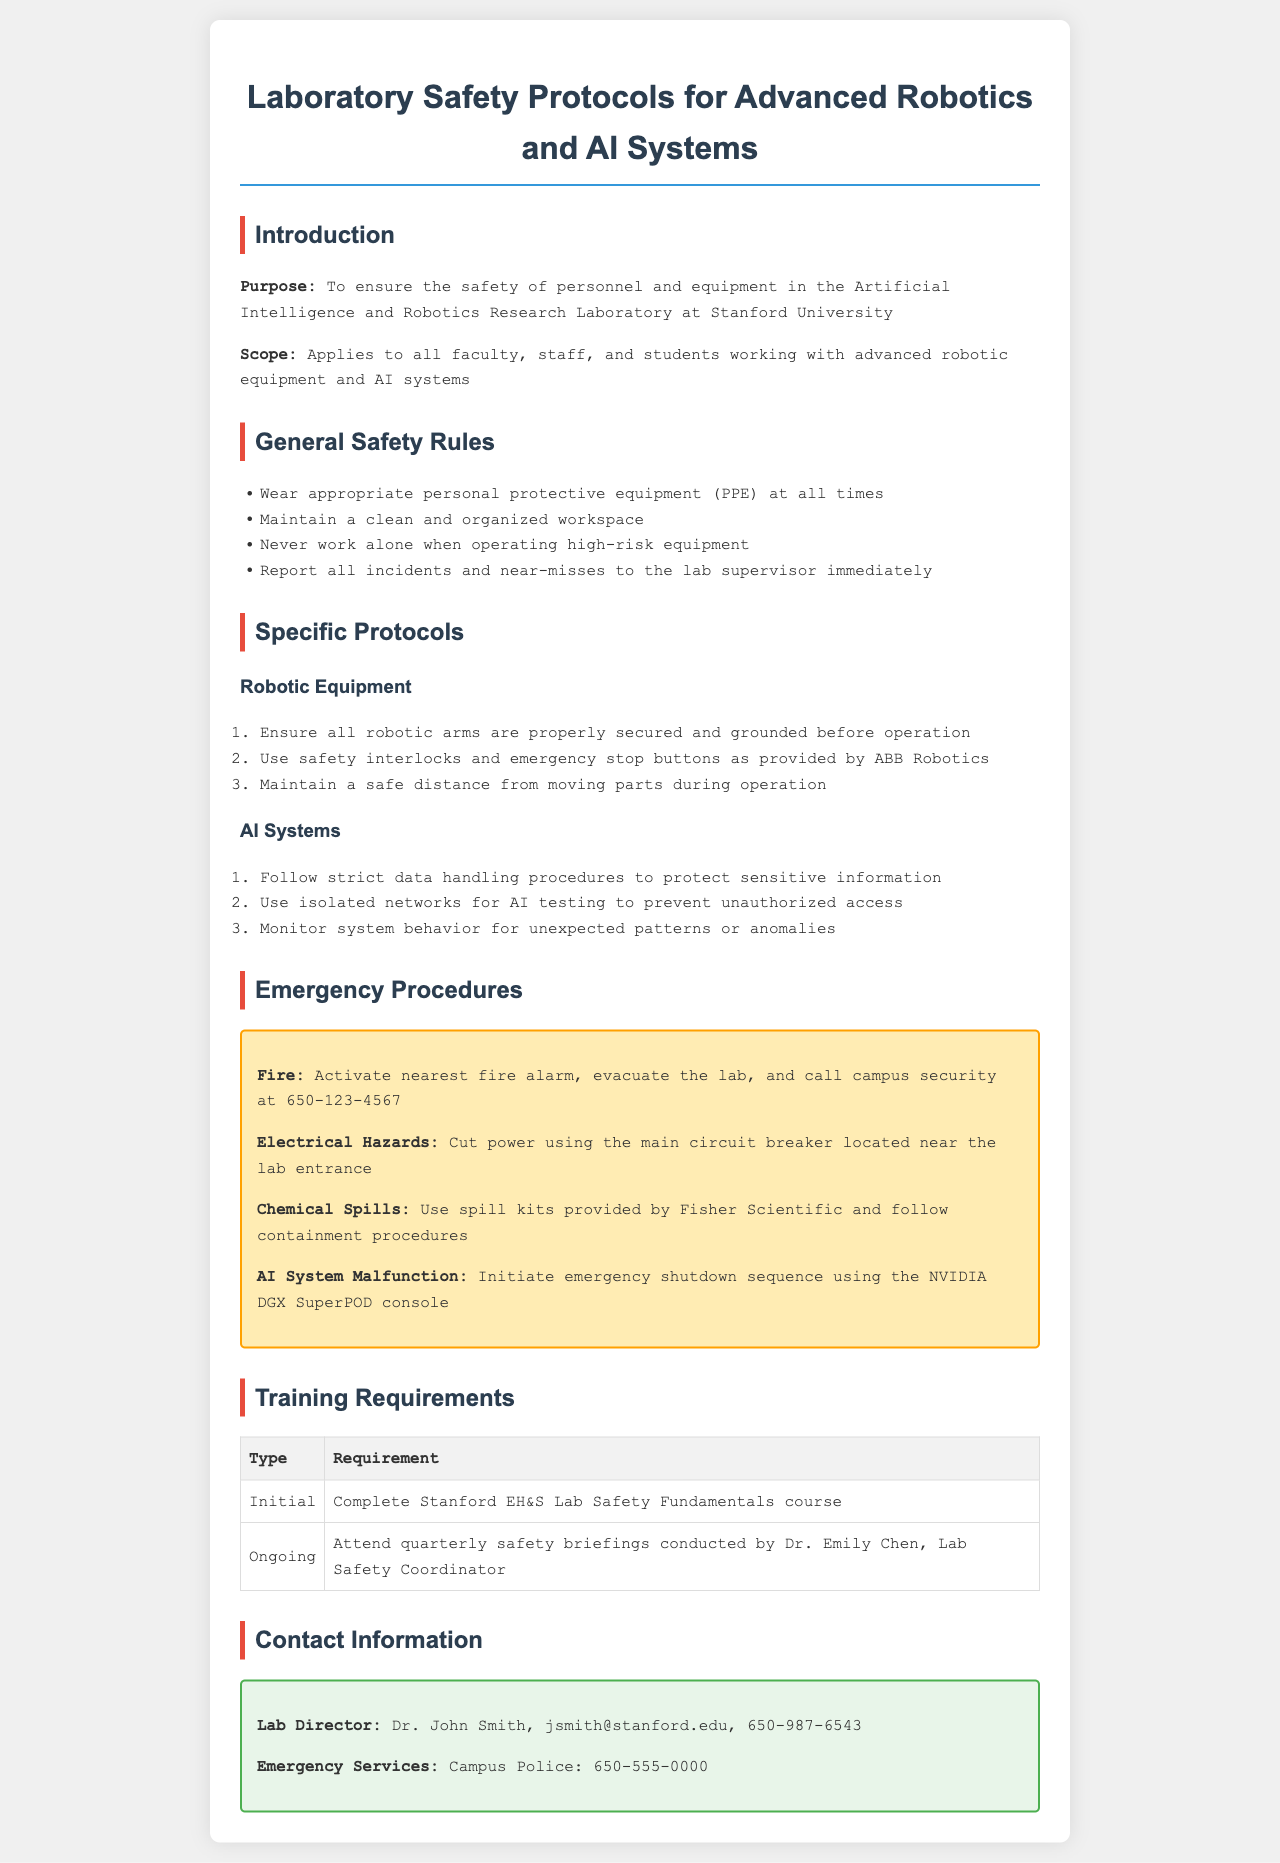What is the purpose of the document? The purpose is to ensure the safety of personnel and equipment in the lab.
Answer: To ensure the safety of personnel and equipment in the Artificial Intelligence and Robotics Research Laboratory at Stanford University Who is the Lab Safety Coordinator? The document states that Dr. Emily Chen conducts safety briefings.
Answer: Dr. Emily Chen What should you do in case of a fire? The document outlines the procedure for fire emergencies.
Answer: Activate nearest fire alarm, evacuate the lab, and call campus security at 650-123-4567 What is required for initial training? The document specifies the training requirements for personnel.
Answer: Complete Stanford EH&S Lab Safety Fundamentals course How often are safety briefings conducted? The document indicates the frequency of ongoing training sessions.
Answer: Quarterly What should be done in case of an AI system malfunction? The document provides specific instructions for AI system emergencies.
Answer: Initiate emergency shutdown sequence using the NVIDIA DGX SuperPOD console What type of protective equipment is required? The general safety rules mention necessary protective measures.
Answer: Personal protective equipment (PPE) How many types of training requirements are listed in the document? The document classifies training requirements into two types.
Answer: Two 